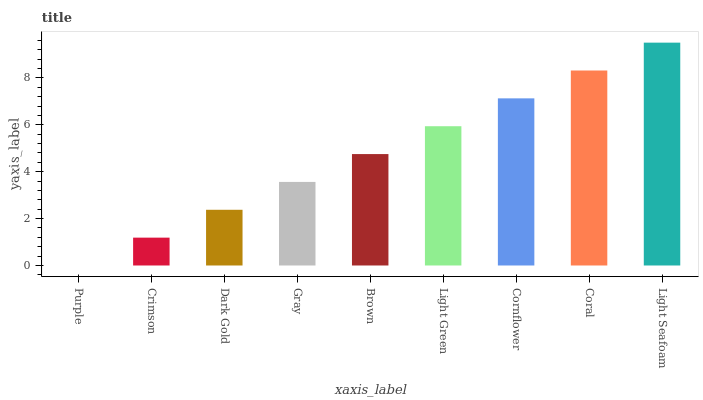Is Purple the minimum?
Answer yes or no. Yes. Is Light Seafoam the maximum?
Answer yes or no. Yes. Is Crimson the minimum?
Answer yes or no. No. Is Crimson the maximum?
Answer yes or no. No. Is Crimson greater than Purple?
Answer yes or no. Yes. Is Purple less than Crimson?
Answer yes or no. Yes. Is Purple greater than Crimson?
Answer yes or no. No. Is Crimson less than Purple?
Answer yes or no. No. Is Brown the high median?
Answer yes or no. Yes. Is Brown the low median?
Answer yes or no. Yes. Is Cornflower the high median?
Answer yes or no. No. Is Cornflower the low median?
Answer yes or no. No. 